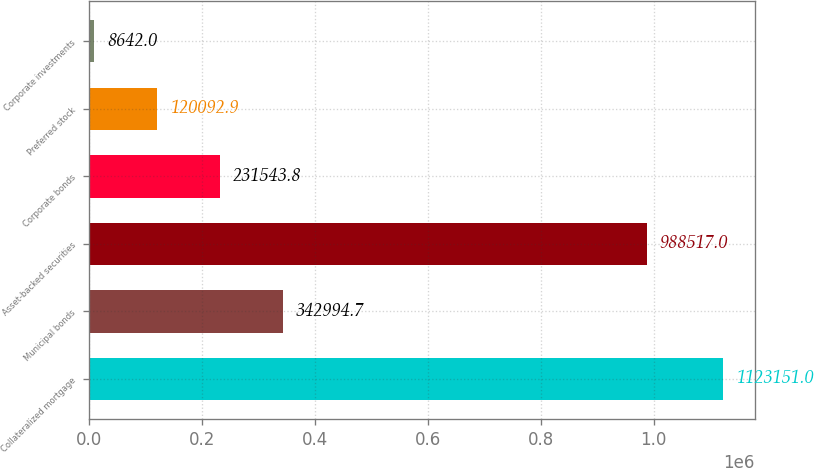Convert chart. <chart><loc_0><loc_0><loc_500><loc_500><bar_chart><fcel>Collateralized mortgage<fcel>Municipal bonds<fcel>Asset-backed securities<fcel>Corporate bonds<fcel>Preferred stock<fcel>Corporate investments<nl><fcel>1.12315e+06<fcel>342995<fcel>988517<fcel>231544<fcel>120093<fcel>8642<nl></chart> 